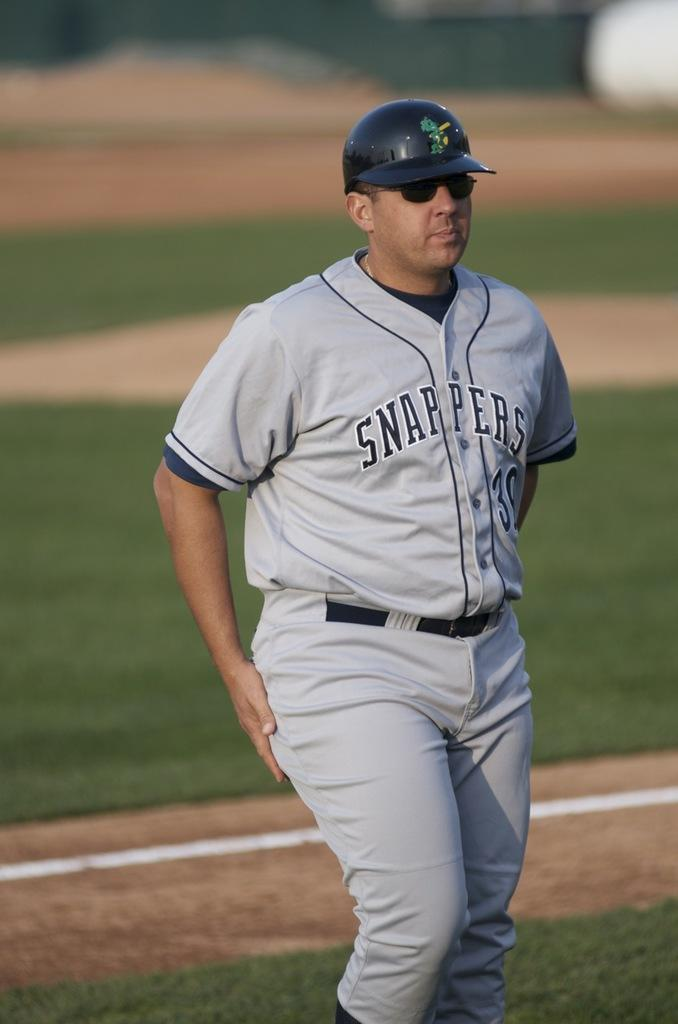Provide a one-sentence caption for the provided image. A player for the Snappers wears sunglasses and a batting helmet. 